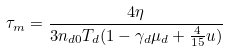<formula> <loc_0><loc_0><loc_500><loc_500>\tau _ { m } = \frac { 4 \eta } { 3 n _ { d 0 } T _ { d } ( 1 - \gamma _ { d } \mu _ { d } + \frac { 4 } { 1 5 } u ) }</formula> 